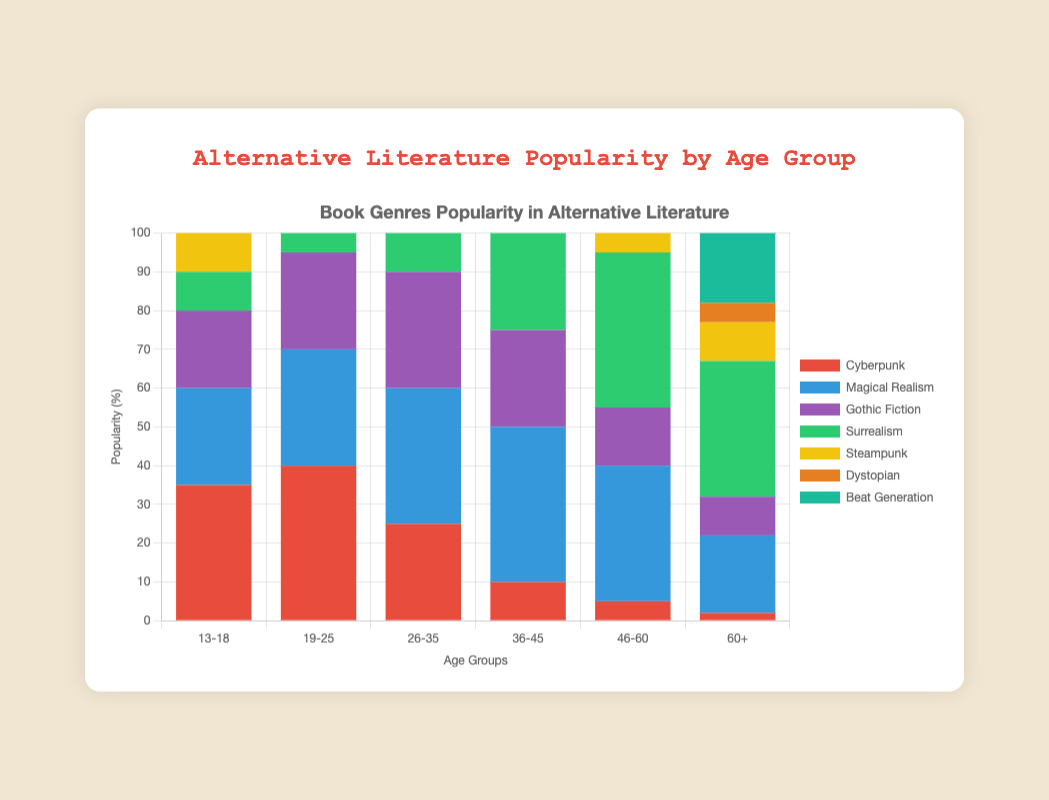Which age group shows the highest popularity for Cyberpunk? Looking at the bar for Cyberpunk, the tallest bar is for the 19-25 age group.
Answer: 19-25 What is the total popularity percentage of Gothic Fiction across all age groups? Summing up the popularity percentages: 20 (13-18) + 25 (19-25) + 30 (26-35) + 25 (36-45) + 15 (46-60) + 10 (60+) gives a total of 125.
Answer: 125% Which genre is the least popular among the 13-18 age group? The shortest bar in the 13-18 group is for Beat Generation with a popularity of 5.
Answer: Beat Generation How does the popularity of Dystopian genre among the 26-35 age group compare to the 36-45 age group? The popularity of Dystopian in the 26-35 age group is 35%, while in the 36-45 age group, it's 20%, making it more popular in the 26-35 age group.
Answer: More popular in 26-35 Which age group has the highest interest in Beat Generation? The tallest bar for Beat Generation is for the 60+ age group, with a popularity of 55%.
Answer: 60+ What is the average popularity percentage of Steampunk across the age groups 19-25, 26-35, and 36-45? The popularity percentages for these age groups are 20 (19-25), 25 (26-35), and 20 (36-45). The average is (20 + 25 + 20) / 3 = 21.67.
Answer: 21.67% Is Magical Realism more popular among the 36-45 age group or the 46-60 age group? The popularity of Magical Realism is 40% in the 36-45 age group and 35% in the 46-60 age group, making it more popular in the 36-45 age group.
Answer: More popular in 36-45 Compare the popularity of Surrealism and Cyberpunk in the 60+ age group. Surrealism has a popularity of 35% while Cyberpunk has only 2%.
Answer: Surrealism is more popular Which genre has the widest range of popularity percentages across different age groups? Beat Generation ranges from 5% to 55%, the widest range among the genres.
Answer: Beat Generation 